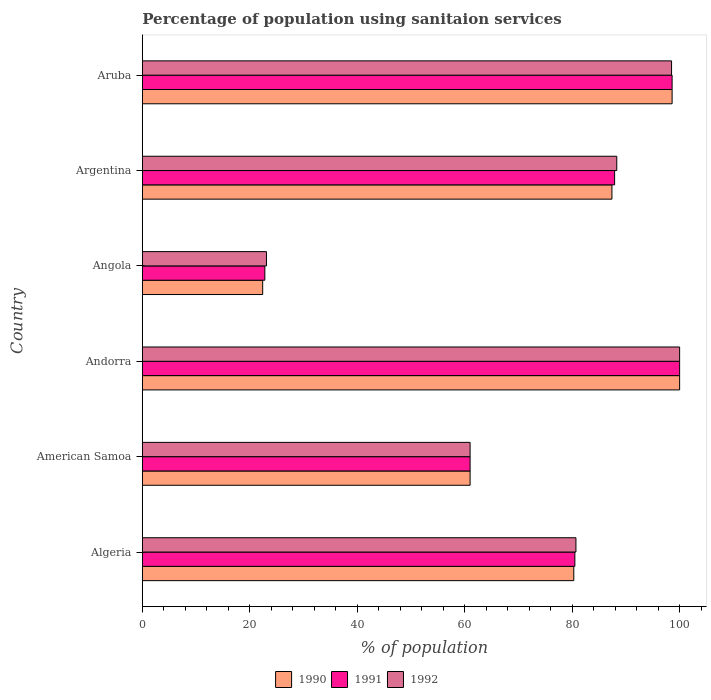How many groups of bars are there?
Make the answer very short. 6. What is the label of the 1st group of bars from the top?
Your answer should be very brief. Aruba. Across all countries, what is the minimum percentage of population using sanitaion services in 1992?
Ensure brevity in your answer.  23.1. In which country was the percentage of population using sanitaion services in 1992 maximum?
Keep it short and to the point. Andorra. In which country was the percentage of population using sanitaion services in 1990 minimum?
Ensure brevity in your answer.  Angola. What is the total percentage of population using sanitaion services in 1990 in the graph?
Make the answer very short. 449.7. What is the difference between the percentage of population using sanitaion services in 1991 in Angola and that in Argentina?
Your answer should be very brief. -65.1. What is the difference between the percentage of population using sanitaion services in 1990 in Argentina and the percentage of population using sanitaion services in 1991 in Aruba?
Give a very brief answer. -11.2. What is the average percentage of population using sanitaion services in 1992 per country?
Your answer should be very brief. 75.27. What is the difference between the percentage of population using sanitaion services in 1991 and percentage of population using sanitaion services in 1992 in Aruba?
Give a very brief answer. 0.1. What is the ratio of the percentage of population using sanitaion services in 1991 in Argentina to that in Aruba?
Provide a short and direct response. 0.89. Is the percentage of population using sanitaion services in 1992 in Algeria less than that in Aruba?
Keep it short and to the point. Yes. Is the difference between the percentage of population using sanitaion services in 1991 in American Samoa and Andorra greater than the difference between the percentage of population using sanitaion services in 1992 in American Samoa and Andorra?
Offer a very short reply. No. What is the difference between the highest and the second highest percentage of population using sanitaion services in 1991?
Offer a very short reply. 1.4. What is the difference between the highest and the lowest percentage of population using sanitaion services in 1991?
Keep it short and to the point. 77.2. What does the 1st bar from the top in American Samoa represents?
Give a very brief answer. 1992. What does the 3rd bar from the bottom in Algeria represents?
Your answer should be very brief. 1992. Is it the case that in every country, the sum of the percentage of population using sanitaion services in 1990 and percentage of population using sanitaion services in 1992 is greater than the percentage of population using sanitaion services in 1991?
Ensure brevity in your answer.  Yes. What is the difference between two consecutive major ticks on the X-axis?
Keep it short and to the point. 20. Are the values on the major ticks of X-axis written in scientific E-notation?
Provide a short and direct response. No. Where does the legend appear in the graph?
Provide a short and direct response. Bottom center. How many legend labels are there?
Provide a short and direct response. 3. How are the legend labels stacked?
Provide a succinct answer. Horizontal. What is the title of the graph?
Ensure brevity in your answer.  Percentage of population using sanitaion services. Does "2009" appear as one of the legend labels in the graph?
Give a very brief answer. No. What is the label or title of the X-axis?
Offer a terse response. % of population. What is the label or title of the Y-axis?
Your answer should be compact. Country. What is the % of population of 1990 in Algeria?
Your response must be concise. 80.3. What is the % of population in 1991 in Algeria?
Offer a very short reply. 80.5. What is the % of population in 1992 in Algeria?
Offer a very short reply. 80.7. What is the % of population in 1990 in American Samoa?
Your answer should be compact. 61. What is the % of population in 1991 in American Samoa?
Offer a very short reply. 61. What is the % of population of 1990 in Andorra?
Your answer should be compact. 100. What is the % of population in 1991 in Andorra?
Your response must be concise. 100. What is the % of population in 1990 in Angola?
Give a very brief answer. 22.4. What is the % of population of 1991 in Angola?
Make the answer very short. 22.8. What is the % of population of 1992 in Angola?
Give a very brief answer. 23.1. What is the % of population of 1990 in Argentina?
Give a very brief answer. 87.4. What is the % of population of 1991 in Argentina?
Provide a succinct answer. 87.9. What is the % of population in 1992 in Argentina?
Your response must be concise. 88.3. What is the % of population of 1990 in Aruba?
Your answer should be compact. 98.6. What is the % of population in 1991 in Aruba?
Provide a succinct answer. 98.6. What is the % of population of 1992 in Aruba?
Keep it short and to the point. 98.5. Across all countries, what is the maximum % of population in 1990?
Give a very brief answer. 100. Across all countries, what is the maximum % of population of 1991?
Offer a very short reply. 100. Across all countries, what is the maximum % of population in 1992?
Your answer should be very brief. 100. Across all countries, what is the minimum % of population of 1990?
Your answer should be compact. 22.4. Across all countries, what is the minimum % of population of 1991?
Your response must be concise. 22.8. Across all countries, what is the minimum % of population in 1992?
Provide a short and direct response. 23.1. What is the total % of population of 1990 in the graph?
Give a very brief answer. 449.7. What is the total % of population in 1991 in the graph?
Your answer should be very brief. 450.8. What is the total % of population of 1992 in the graph?
Make the answer very short. 451.6. What is the difference between the % of population of 1990 in Algeria and that in American Samoa?
Offer a terse response. 19.3. What is the difference between the % of population in 1991 in Algeria and that in American Samoa?
Make the answer very short. 19.5. What is the difference between the % of population in 1990 in Algeria and that in Andorra?
Give a very brief answer. -19.7. What is the difference between the % of population of 1991 in Algeria and that in Andorra?
Ensure brevity in your answer.  -19.5. What is the difference between the % of population of 1992 in Algeria and that in Andorra?
Your answer should be compact. -19.3. What is the difference between the % of population in 1990 in Algeria and that in Angola?
Offer a terse response. 57.9. What is the difference between the % of population in 1991 in Algeria and that in Angola?
Your response must be concise. 57.7. What is the difference between the % of population of 1992 in Algeria and that in Angola?
Provide a short and direct response. 57.6. What is the difference between the % of population of 1990 in Algeria and that in Argentina?
Provide a succinct answer. -7.1. What is the difference between the % of population in 1991 in Algeria and that in Argentina?
Give a very brief answer. -7.4. What is the difference between the % of population in 1992 in Algeria and that in Argentina?
Make the answer very short. -7.6. What is the difference between the % of population in 1990 in Algeria and that in Aruba?
Make the answer very short. -18.3. What is the difference between the % of population of 1991 in Algeria and that in Aruba?
Ensure brevity in your answer.  -18.1. What is the difference between the % of population of 1992 in Algeria and that in Aruba?
Give a very brief answer. -17.8. What is the difference between the % of population of 1990 in American Samoa and that in Andorra?
Your answer should be compact. -39. What is the difference between the % of population of 1991 in American Samoa and that in Andorra?
Your response must be concise. -39. What is the difference between the % of population of 1992 in American Samoa and that in Andorra?
Your answer should be compact. -39. What is the difference between the % of population in 1990 in American Samoa and that in Angola?
Provide a short and direct response. 38.6. What is the difference between the % of population in 1991 in American Samoa and that in Angola?
Your answer should be compact. 38.2. What is the difference between the % of population in 1992 in American Samoa and that in Angola?
Give a very brief answer. 37.9. What is the difference between the % of population of 1990 in American Samoa and that in Argentina?
Provide a succinct answer. -26.4. What is the difference between the % of population of 1991 in American Samoa and that in Argentina?
Make the answer very short. -26.9. What is the difference between the % of population of 1992 in American Samoa and that in Argentina?
Ensure brevity in your answer.  -27.3. What is the difference between the % of population of 1990 in American Samoa and that in Aruba?
Offer a terse response. -37.6. What is the difference between the % of population of 1991 in American Samoa and that in Aruba?
Your answer should be very brief. -37.6. What is the difference between the % of population of 1992 in American Samoa and that in Aruba?
Offer a very short reply. -37.5. What is the difference between the % of population in 1990 in Andorra and that in Angola?
Give a very brief answer. 77.6. What is the difference between the % of population of 1991 in Andorra and that in Angola?
Make the answer very short. 77.2. What is the difference between the % of population in 1992 in Andorra and that in Angola?
Your response must be concise. 76.9. What is the difference between the % of population of 1990 in Andorra and that in Argentina?
Provide a succinct answer. 12.6. What is the difference between the % of population of 1992 in Andorra and that in Argentina?
Make the answer very short. 11.7. What is the difference between the % of population in 1990 in Andorra and that in Aruba?
Ensure brevity in your answer.  1.4. What is the difference between the % of population of 1991 in Andorra and that in Aruba?
Ensure brevity in your answer.  1.4. What is the difference between the % of population of 1990 in Angola and that in Argentina?
Your answer should be compact. -65. What is the difference between the % of population in 1991 in Angola and that in Argentina?
Keep it short and to the point. -65.1. What is the difference between the % of population of 1992 in Angola and that in Argentina?
Your answer should be compact. -65.2. What is the difference between the % of population of 1990 in Angola and that in Aruba?
Make the answer very short. -76.2. What is the difference between the % of population of 1991 in Angola and that in Aruba?
Ensure brevity in your answer.  -75.8. What is the difference between the % of population of 1992 in Angola and that in Aruba?
Make the answer very short. -75.4. What is the difference between the % of population in 1991 in Argentina and that in Aruba?
Your answer should be very brief. -10.7. What is the difference between the % of population of 1992 in Argentina and that in Aruba?
Make the answer very short. -10.2. What is the difference between the % of population of 1990 in Algeria and the % of population of 1991 in American Samoa?
Provide a short and direct response. 19.3. What is the difference between the % of population of 1990 in Algeria and the % of population of 1992 in American Samoa?
Offer a very short reply. 19.3. What is the difference between the % of population of 1991 in Algeria and the % of population of 1992 in American Samoa?
Keep it short and to the point. 19.5. What is the difference between the % of population in 1990 in Algeria and the % of population in 1991 in Andorra?
Keep it short and to the point. -19.7. What is the difference between the % of population in 1990 in Algeria and the % of population in 1992 in Andorra?
Provide a short and direct response. -19.7. What is the difference between the % of population of 1991 in Algeria and the % of population of 1992 in Andorra?
Provide a short and direct response. -19.5. What is the difference between the % of population of 1990 in Algeria and the % of population of 1991 in Angola?
Offer a terse response. 57.5. What is the difference between the % of population in 1990 in Algeria and the % of population in 1992 in Angola?
Ensure brevity in your answer.  57.2. What is the difference between the % of population of 1991 in Algeria and the % of population of 1992 in Angola?
Provide a succinct answer. 57.4. What is the difference between the % of population in 1990 in Algeria and the % of population in 1992 in Argentina?
Your answer should be compact. -8. What is the difference between the % of population in 1991 in Algeria and the % of population in 1992 in Argentina?
Give a very brief answer. -7.8. What is the difference between the % of population in 1990 in Algeria and the % of population in 1991 in Aruba?
Keep it short and to the point. -18.3. What is the difference between the % of population of 1990 in Algeria and the % of population of 1992 in Aruba?
Offer a terse response. -18.2. What is the difference between the % of population of 1991 in Algeria and the % of population of 1992 in Aruba?
Your answer should be very brief. -18. What is the difference between the % of population of 1990 in American Samoa and the % of population of 1991 in Andorra?
Your answer should be compact. -39. What is the difference between the % of population of 1990 in American Samoa and the % of population of 1992 in Andorra?
Offer a very short reply. -39. What is the difference between the % of population of 1991 in American Samoa and the % of population of 1992 in Andorra?
Your response must be concise. -39. What is the difference between the % of population of 1990 in American Samoa and the % of population of 1991 in Angola?
Keep it short and to the point. 38.2. What is the difference between the % of population of 1990 in American Samoa and the % of population of 1992 in Angola?
Provide a succinct answer. 37.9. What is the difference between the % of population in 1991 in American Samoa and the % of population in 1992 in Angola?
Your response must be concise. 37.9. What is the difference between the % of population in 1990 in American Samoa and the % of population in 1991 in Argentina?
Offer a terse response. -26.9. What is the difference between the % of population of 1990 in American Samoa and the % of population of 1992 in Argentina?
Your answer should be very brief. -27.3. What is the difference between the % of population of 1991 in American Samoa and the % of population of 1992 in Argentina?
Provide a short and direct response. -27.3. What is the difference between the % of population in 1990 in American Samoa and the % of population in 1991 in Aruba?
Your answer should be compact. -37.6. What is the difference between the % of population of 1990 in American Samoa and the % of population of 1992 in Aruba?
Keep it short and to the point. -37.5. What is the difference between the % of population in 1991 in American Samoa and the % of population in 1992 in Aruba?
Provide a short and direct response. -37.5. What is the difference between the % of population in 1990 in Andorra and the % of population in 1991 in Angola?
Give a very brief answer. 77.2. What is the difference between the % of population in 1990 in Andorra and the % of population in 1992 in Angola?
Offer a terse response. 76.9. What is the difference between the % of population of 1991 in Andorra and the % of population of 1992 in Angola?
Your response must be concise. 76.9. What is the difference between the % of population of 1990 in Andorra and the % of population of 1991 in Argentina?
Your answer should be compact. 12.1. What is the difference between the % of population in 1990 in Andorra and the % of population in 1992 in Aruba?
Give a very brief answer. 1.5. What is the difference between the % of population of 1990 in Angola and the % of population of 1991 in Argentina?
Keep it short and to the point. -65.5. What is the difference between the % of population of 1990 in Angola and the % of population of 1992 in Argentina?
Provide a short and direct response. -65.9. What is the difference between the % of population of 1991 in Angola and the % of population of 1992 in Argentina?
Give a very brief answer. -65.5. What is the difference between the % of population of 1990 in Angola and the % of population of 1991 in Aruba?
Offer a very short reply. -76.2. What is the difference between the % of population in 1990 in Angola and the % of population in 1992 in Aruba?
Ensure brevity in your answer.  -76.1. What is the difference between the % of population of 1991 in Angola and the % of population of 1992 in Aruba?
Provide a succinct answer. -75.7. What is the difference between the % of population in 1990 in Argentina and the % of population in 1991 in Aruba?
Offer a terse response. -11.2. What is the difference between the % of population of 1991 in Argentina and the % of population of 1992 in Aruba?
Your answer should be compact. -10.6. What is the average % of population of 1990 per country?
Ensure brevity in your answer.  74.95. What is the average % of population of 1991 per country?
Make the answer very short. 75.13. What is the average % of population of 1992 per country?
Provide a succinct answer. 75.27. What is the difference between the % of population in 1990 and % of population in 1991 in American Samoa?
Your response must be concise. 0. What is the difference between the % of population of 1990 and % of population of 1992 in American Samoa?
Your answer should be compact. 0. What is the difference between the % of population of 1990 and % of population of 1991 in Andorra?
Keep it short and to the point. 0. What is the difference between the % of population in 1991 and % of population in 1992 in Andorra?
Offer a very short reply. 0. What is the difference between the % of population of 1991 and % of population of 1992 in Angola?
Make the answer very short. -0.3. What is the difference between the % of population in 1990 and % of population in 1991 in Aruba?
Your answer should be compact. 0. What is the difference between the % of population of 1991 and % of population of 1992 in Aruba?
Your response must be concise. 0.1. What is the ratio of the % of population in 1990 in Algeria to that in American Samoa?
Provide a succinct answer. 1.32. What is the ratio of the % of population of 1991 in Algeria to that in American Samoa?
Ensure brevity in your answer.  1.32. What is the ratio of the % of population in 1992 in Algeria to that in American Samoa?
Your response must be concise. 1.32. What is the ratio of the % of population of 1990 in Algeria to that in Andorra?
Your answer should be very brief. 0.8. What is the ratio of the % of population of 1991 in Algeria to that in Andorra?
Ensure brevity in your answer.  0.81. What is the ratio of the % of population in 1992 in Algeria to that in Andorra?
Make the answer very short. 0.81. What is the ratio of the % of population in 1990 in Algeria to that in Angola?
Give a very brief answer. 3.58. What is the ratio of the % of population of 1991 in Algeria to that in Angola?
Keep it short and to the point. 3.53. What is the ratio of the % of population in 1992 in Algeria to that in Angola?
Offer a terse response. 3.49. What is the ratio of the % of population in 1990 in Algeria to that in Argentina?
Provide a short and direct response. 0.92. What is the ratio of the % of population of 1991 in Algeria to that in Argentina?
Offer a terse response. 0.92. What is the ratio of the % of population in 1992 in Algeria to that in Argentina?
Offer a terse response. 0.91. What is the ratio of the % of population of 1990 in Algeria to that in Aruba?
Your response must be concise. 0.81. What is the ratio of the % of population in 1991 in Algeria to that in Aruba?
Give a very brief answer. 0.82. What is the ratio of the % of population of 1992 in Algeria to that in Aruba?
Your answer should be very brief. 0.82. What is the ratio of the % of population in 1990 in American Samoa to that in Andorra?
Give a very brief answer. 0.61. What is the ratio of the % of population in 1991 in American Samoa to that in Andorra?
Make the answer very short. 0.61. What is the ratio of the % of population in 1992 in American Samoa to that in Andorra?
Offer a terse response. 0.61. What is the ratio of the % of population of 1990 in American Samoa to that in Angola?
Your answer should be very brief. 2.72. What is the ratio of the % of population of 1991 in American Samoa to that in Angola?
Provide a short and direct response. 2.68. What is the ratio of the % of population in 1992 in American Samoa to that in Angola?
Offer a terse response. 2.64. What is the ratio of the % of population of 1990 in American Samoa to that in Argentina?
Make the answer very short. 0.7. What is the ratio of the % of population of 1991 in American Samoa to that in Argentina?
Ensure brevity in your answer.  0.69. What is the ratio of the % of population in 1992 in American Samoa to that in Argentina?
Offer a terse response. 0.69. What is the ratio of the % of population in 1990 in American Samoa to that in Aruba?
Provide a succinct answer. 0.62. What is the ratio of the % of population in 1991 in American Samoa to that in Aruba?
Offer a terse response. 0.62. What is the ratio of the % of population of 1992 in American Samoa to that in Aruba?
Offer a very short reply. 0.62. What is the ratio of the % of population of 1990 in Andorra to that in Angola?
Provide a succinct answer. 4.46. What is the ratio of the % of population of 1991 in Andorra to that in Angola?
Provide a succinct answer. 4.39. What is the ratio of the % of population of 1992 in Andorra to that in Angola?
Provide a short and direct response. 4.33. What is the ratio of the % of population of 1990 in Andorra to that in Argentina?
Give a very brief answer. 1.14. What is the ratio of the % of population of 1991 in Andorra to that in Argentina?
Ensure brevity in your answer.  1.14. What is the ratio of the % of population of 1992 in Andorra to that in Argentina?
Make the answer very short. 1.13. What is the ratio of the % of population of 1990 in Andorra to that in Aruba?
Ensure brevity in your answer.  1.01. What is the ratio of the % of population of 1991 in Andorra to that in Aruba?
Your response must be concise. 1.01. What is the ratio of the % of population in 1992 in Andorra to that in Aruba?
Give a very brief answer. 1.02. What is the ratio of the % of population in 1990 in Angola to that in Argentina?
Your answer should be very brief. 0.26. What is the ratio of the % of population in 1991 in Angola to that in Argentina?
Provide a succinct answer. 0.26. What is the ratio of the % of population of 1992 in Angola to that in Argentina?
Your answer should be very brief. 0.26. What is the ratio of the % of population of 1990 in Angola to that in Aruba?
Provide a succinct answer. 0.23. What is the ratio of the % of population in 1991 in Angola to that in Aruba?
Offer a terse response. 0.23. What is the ratio of the % of population in 1992 in Angola to that in Aruba?
Provide a short and direct response. 0.23. What is the ratio of the % of population of 1990 in Argentina to that in Aruba?
Your response must be concise. 0.89. What is the ratio of the % of population in 1991 in Argentina to that in Aruba?
Offer a very short reply. 0.89. What is the ratio of the % of population in 1992 in Argentina to that in Aruba?
Provide a short and direct response. 0.9. What is the difference between the highest and the second highest % of population of 1991?
Your answer should be compact. 1.4. What is the difference between the highest and the lowest % of population of 1990?
Provide a short and direct response. 77.6. What is the difference between the highest and the lowest % of population of 1991?
Give a very brief answer. 77.2. What is the difference between the highest and the lowest % of population in 1992?
Give a very brief answer. 76.9. 